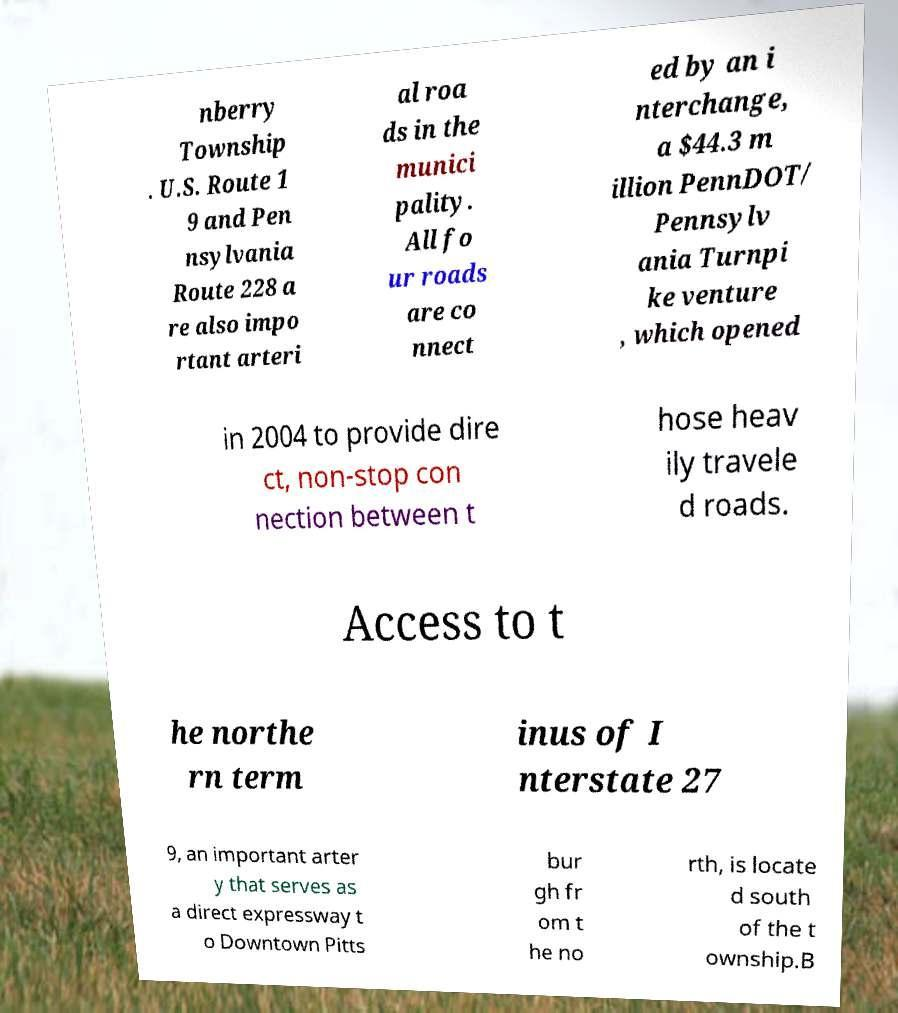What messages or text are displayed in this image? I need them in a readable, typed format. nberry Township . U.S. Route 1 9 and Pen nsylvania Route 228 a re also impo rtant arteri al roa ds in the munici pality. All fo ur roads are co nnect ed by an i nterchange, a $44.3 m illion PennDOT/ Pennsylv ania Turnpi ke venture , which opened in 2004 to provide dire ct, non-stop con nection between t hose heav ily travele d roads. Access to t he northe rn term inus of I nterstate 27 9, an important arter y that serves as a direct expressway t o Downtown Pitts bur gh fr om t he no rth, is locate d south of the t ownship.B 